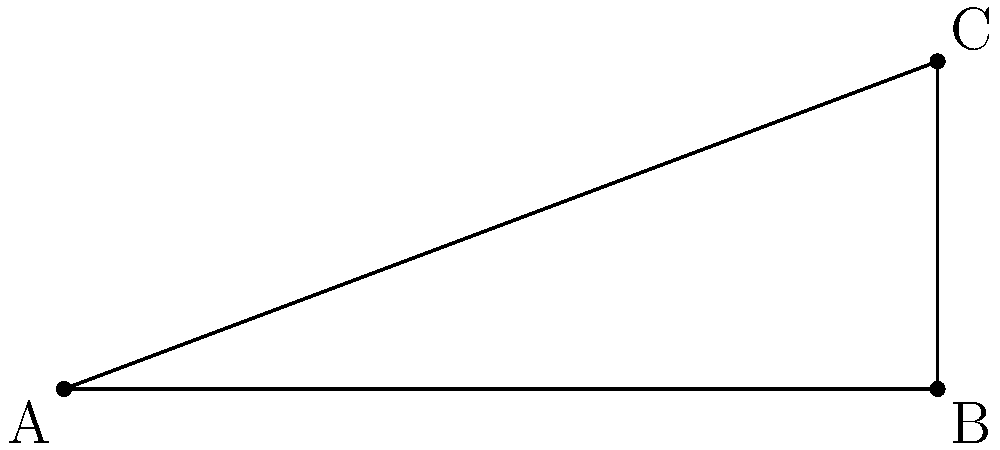As a swimming coach, you're inspecting a new diving board installation. The board extends 8 meters horizontally from its base and reaches a height of 3 meters at its tip. What is the angle $\theta$ between the diving board and the water's surface? Let's approach this step-by-step using traditional geometric principles:

1) We have a right triangle formed by the diving board, the water surface, and an imaginary vertical line from the tip of the board to the water.

2) We know:
   - The horizontal distance (adjacent side) is 8 meters
   - The vertical height (opposite side) is 3 meters

3) To find the angle $\theta$, we can use the tangent function:

   $\tan(\theta) = \frac{\text{opposite}}{\text{adjacent}} = \frac{3}{8}$

4) To get $\theta$, we need to take the inverse tangent (arctangent):

   $\theta = \tan^{-1}(\frac{3}{8})$

5) Using a calculator or trigonometric tables:

   $\theta \approx 20.56°$

6) Rounding to the nearest degree:

   $\theta \approx 21°$

This angle ensures a proper trajectory for divers, allowing them to enter the water safely. As an experienced coach, you know that the right angle is crucial for both performance and safety.
Answer: $21°$ 